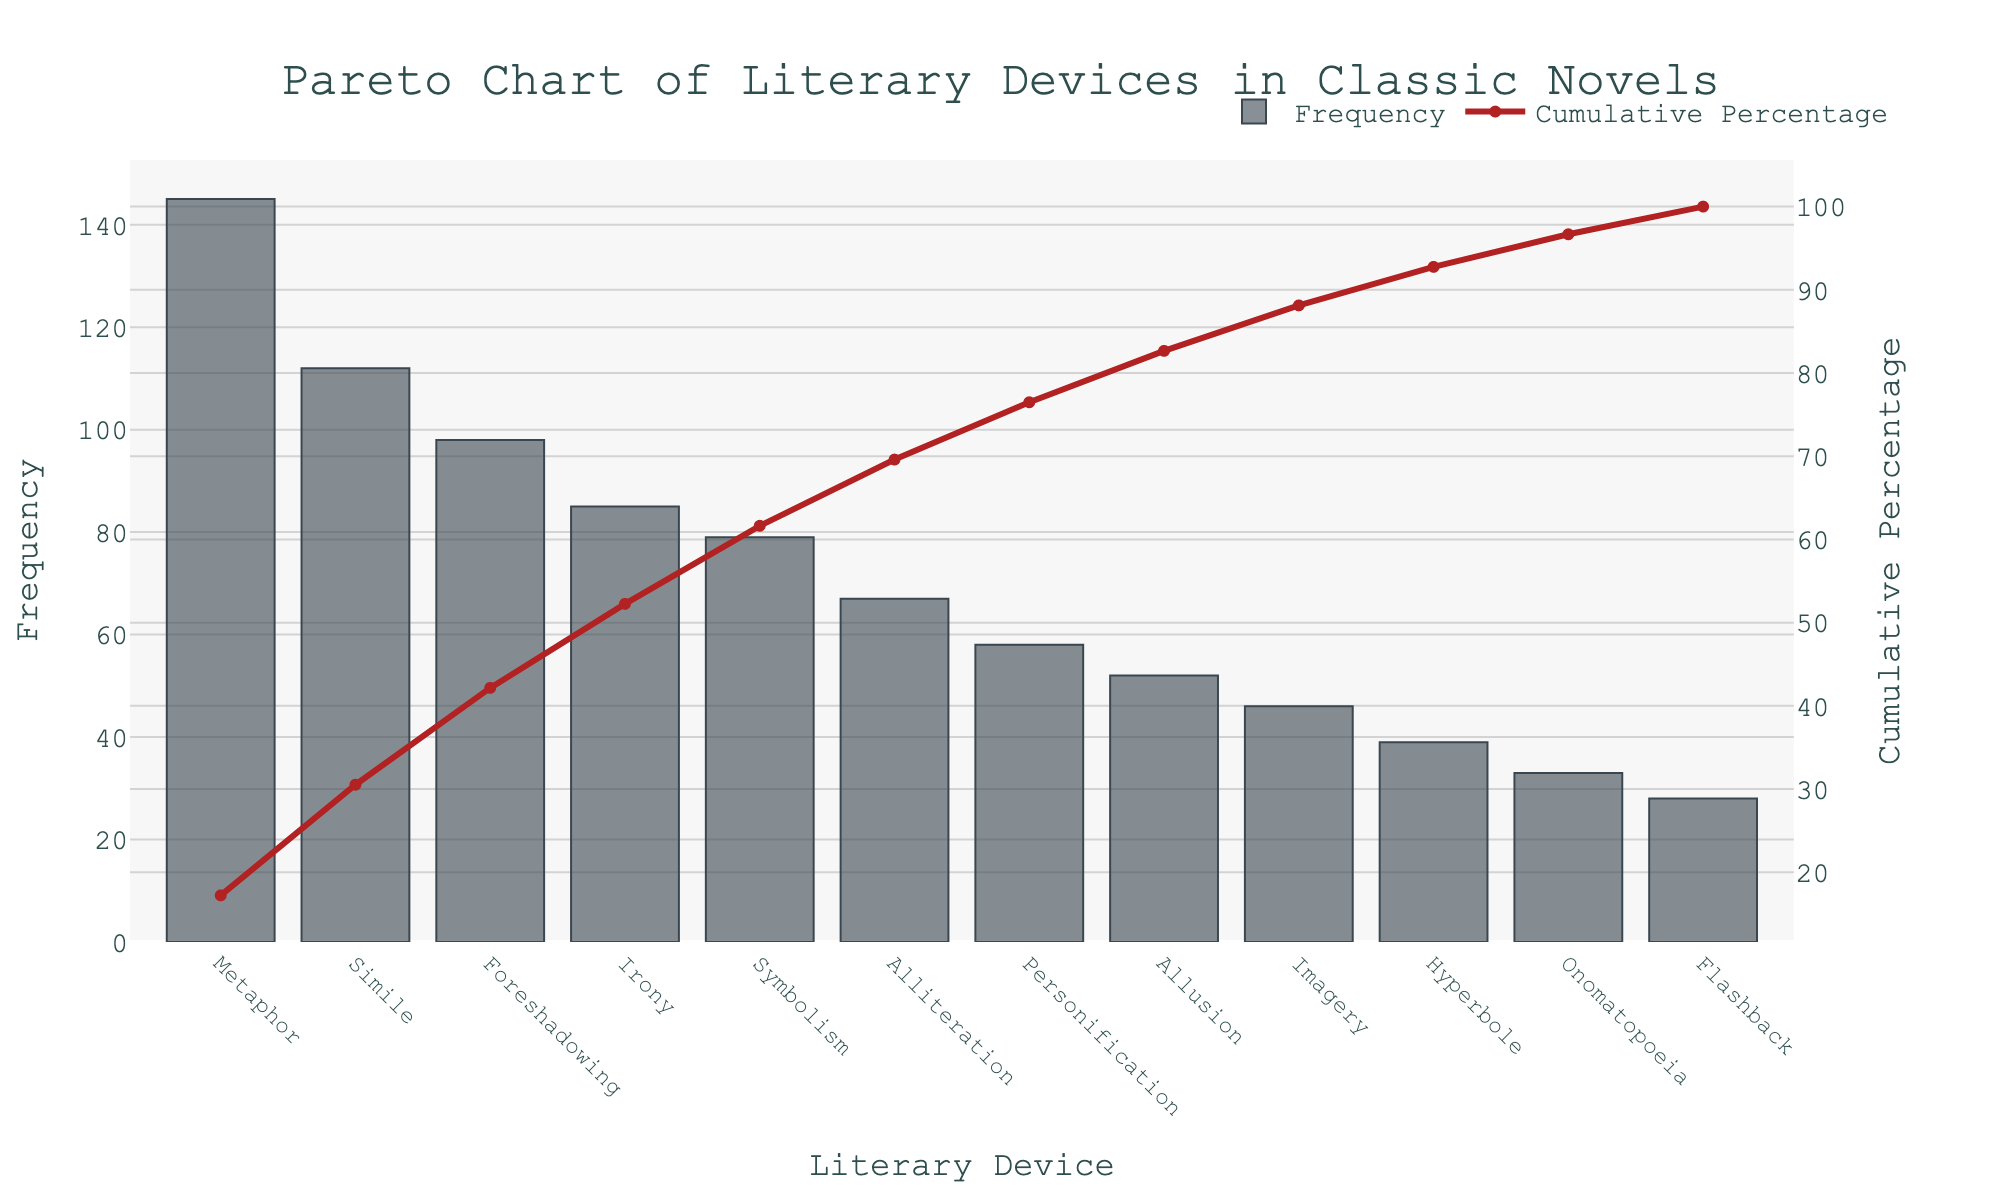How many literary devices are represented in the chart? Count the number of different literary devices listed along the x-axis.
Answer: 12 Which literary device has the highest frequency? Find the tallest bar within the chart and read the label on the x-axis directly below it.
Answer: Metaphor What is the cumulative percentage of the top three most prevalent literary devices? Sum the cumulative percentages at the third literary device in the ordered list: Metaphor (Metaphor + Simile + Foreshadowing).
Answer: 50.73% How does the frequency of Irony compare to that of Hyperbole? Locate the bars for Irony and Hyperbole and compare their heights or read the values. Irony has a frequency of 85, and Hyperbole has 39.
Answer: Irony has a higher frequency Which literary devices contribute to reaching approximately 80% cumulative percentage? Identify the literary devices until the cumulative percentage line crosses the 80% mark: Metaphor, Simile, Foreshadowing, Irony, and Symbolism.
Answer: Metaphor, Simile, Foreshadowing, Irony, Symbolism What is the approximate cumulative percentage after including Symbolism? Find the cumulative percentage at Symbolism.
Answer: 79.6% What is the frequency difference between the literary device with the highest frequency and the literary device with the lowest frequency? Subtract the frequency of the lowest (Flashback) from the frequency of the highest (Metaphor).
Answer: 117 Which devices' frequencies lie between 50 and 100? Identify the bars whose heights (frequencies) are between 50 and 100: Foreshadowing (98), Irony (85), Symbolism (79), Alliteration (67), Personification (58), and Allusion (52).
Answer: Foreshadowing, Irony, Symbolism, Alliteration, Personification, Allusion 